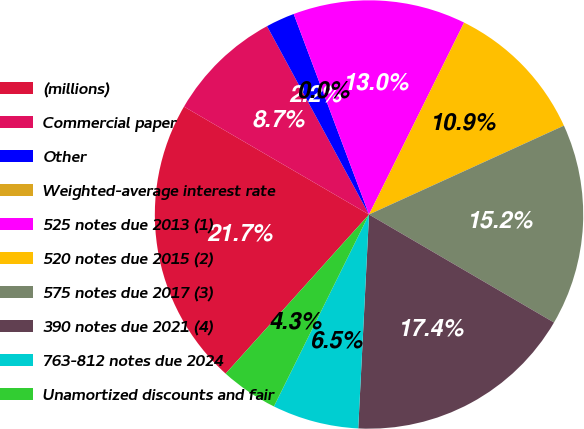Convert chart to OTSL. <chart><loc_0><loc_0><loc_500><loc_500><pie_chart><fcel>(millions)<fcel>Commercial paper<fcel>Other<fcel>Weighted-average interest rate<fcel>525 notes due 2013 (1)<fcel>520 notes due 2015 (2)<fcel>575 notes due 2017 (3)<fcel>390 notes due 2021 (4)<fcel>763-812 notes due 2024<fcel>Unamortized discounts and fair<nl><fcel>21.73%<fcel>8.7%<fcel>2.18%<fcel>0.0%<fcel>13.04%<fcel>10.87%<fcel>15.22%<fcel>17.39%<fcel>6.52%<fcel>4.35%<nl></chart> 